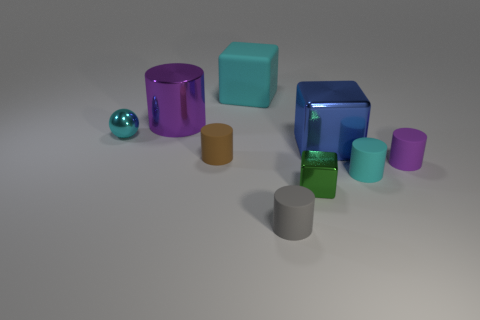Do the cyan block and the cyan cylinder have the same material? While both the cyan block and the cyan cylinder exhibit a similar hue, discerning whether they have the same material requires a closer look. They both appear to have a reflective surface, suggesting they might indeed share similar material properties, such as glossiness or smoothness. However, without additional information or context, it's not possible to confirm with absolute certainty if they are made of the identical substance. 